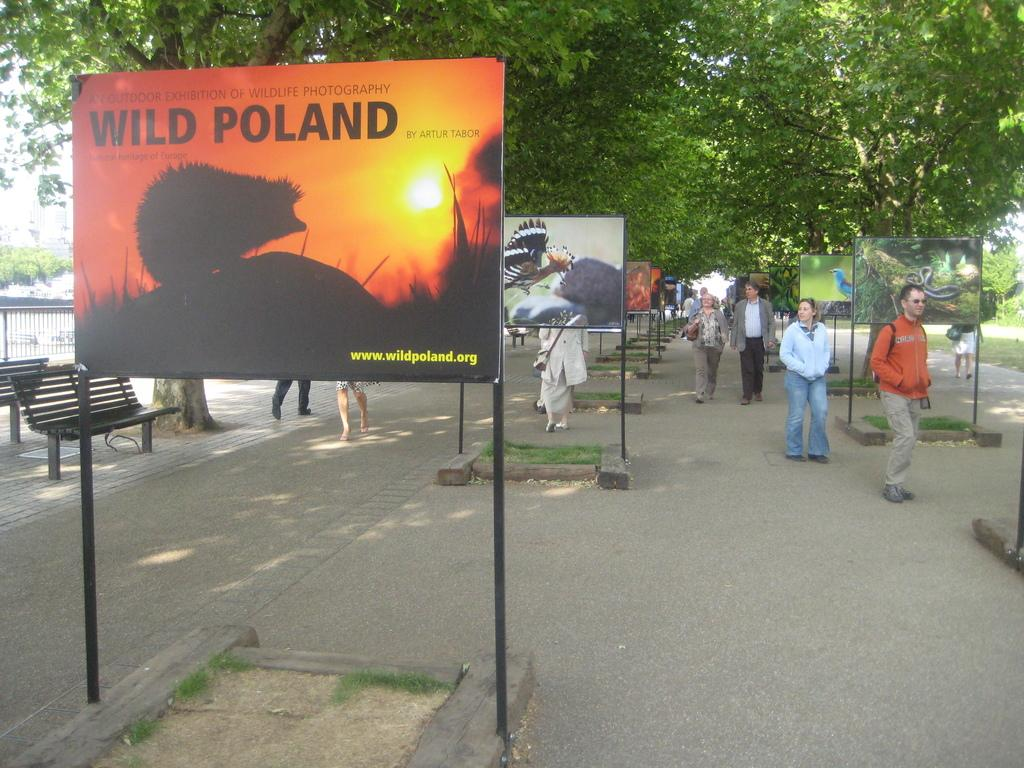<image>
Offer a succinct explanation of the picture presented. A large sign on a path that says wild Poland on it. 